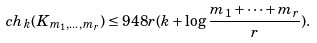<formula> <loc_0><loc_0><loc_500><loc_500>c h _ { k } ( K _ { m _ { 1 } , \dots , m _ { r } } ) \leq 9 4 8 r ( k + \log { \frac { m _ { 1 } + \cdots + m _ { r } } { r } } ) .</formula> 